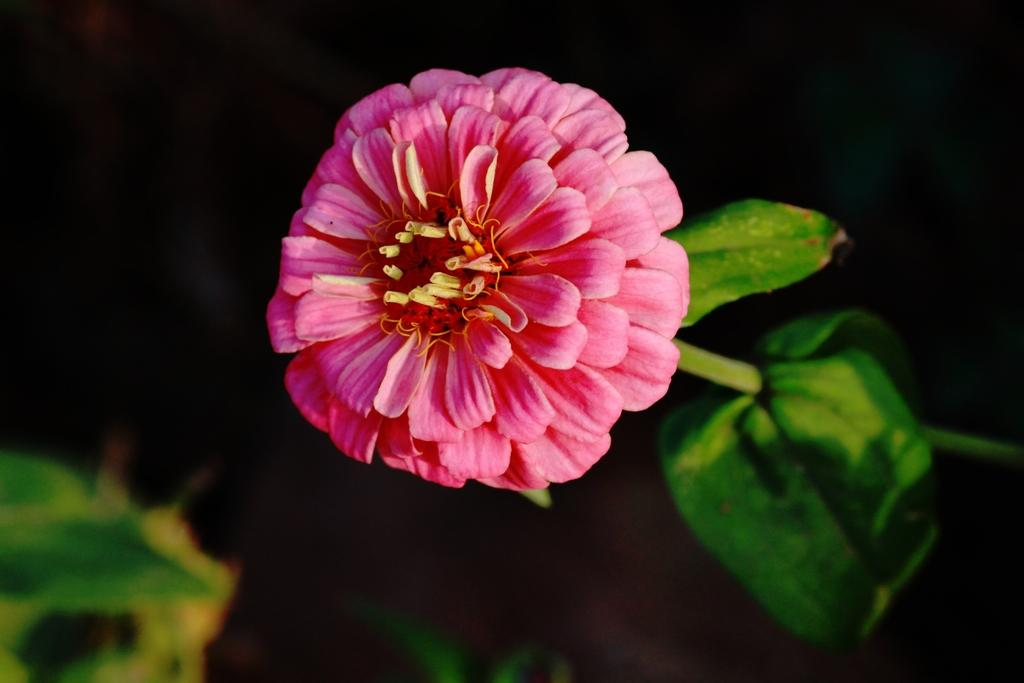What type of plant can be seen in the image? There is a flower in the image. What else is present on the plant besides the flower? There are leaves in the image. What color is the background of the image? The background of the image is black. What riddle is the flower trying to solve in the image? There is no indication in the image that the flower is trying to solve a riddle. 